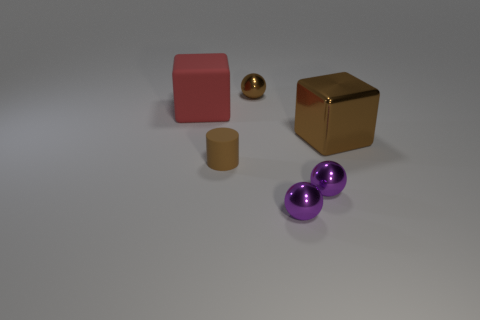What material is the ball that is the same color as the large metallic block?
Your response must be concise. Metal. How many large things are the same color as the large rubber block?
Your answer should be very brief. 0. Is the size of the brown cylinder the same as the metallic sphere behind the brown rubber cylinder?
Give a very brief answer. Yes. There is a block that is on the left side of the tiny metal ball behind the cube behind the large metal block; how big is it?
Offer a very short reply. Large. There is a brown rubber object; how many shiny objects are behind it?
Provide a short and direct response. 2. The small brown object to the left of the small brown thing behind the small cylinder is made of what material?
Keep it short and to the point. Rubber. Is there anything else that is the same size as the brown metallic sphere?
Offer a very short reply. Yes. Do the brown matte thing and the red object have the same size?
Offer a very short reply. No. What number of things are big things left of the small rubber cylinder or brown metallic things on the right side of the brown shiny sphere?
Offer a very short reply. 2. Is the number of brown cubes behind the matte cube greater than the number of gray metallic things?
Ensure brevity in your answer.  No. 